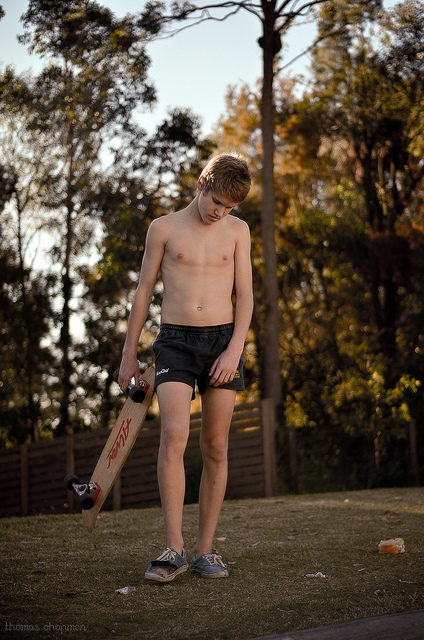<image>Brand of the man's shoes? It is unknown what the brand of the man's shoes is. It could be any of multiple options including 'sketchers', 'vans', 'keds', 'toms', 'dockers', 'generic', 'nikes', or 'lecoq'. Brand of the man's shoes? It is unknown what brand of shoes the man is wearing. It could be any of the mentioned options. 